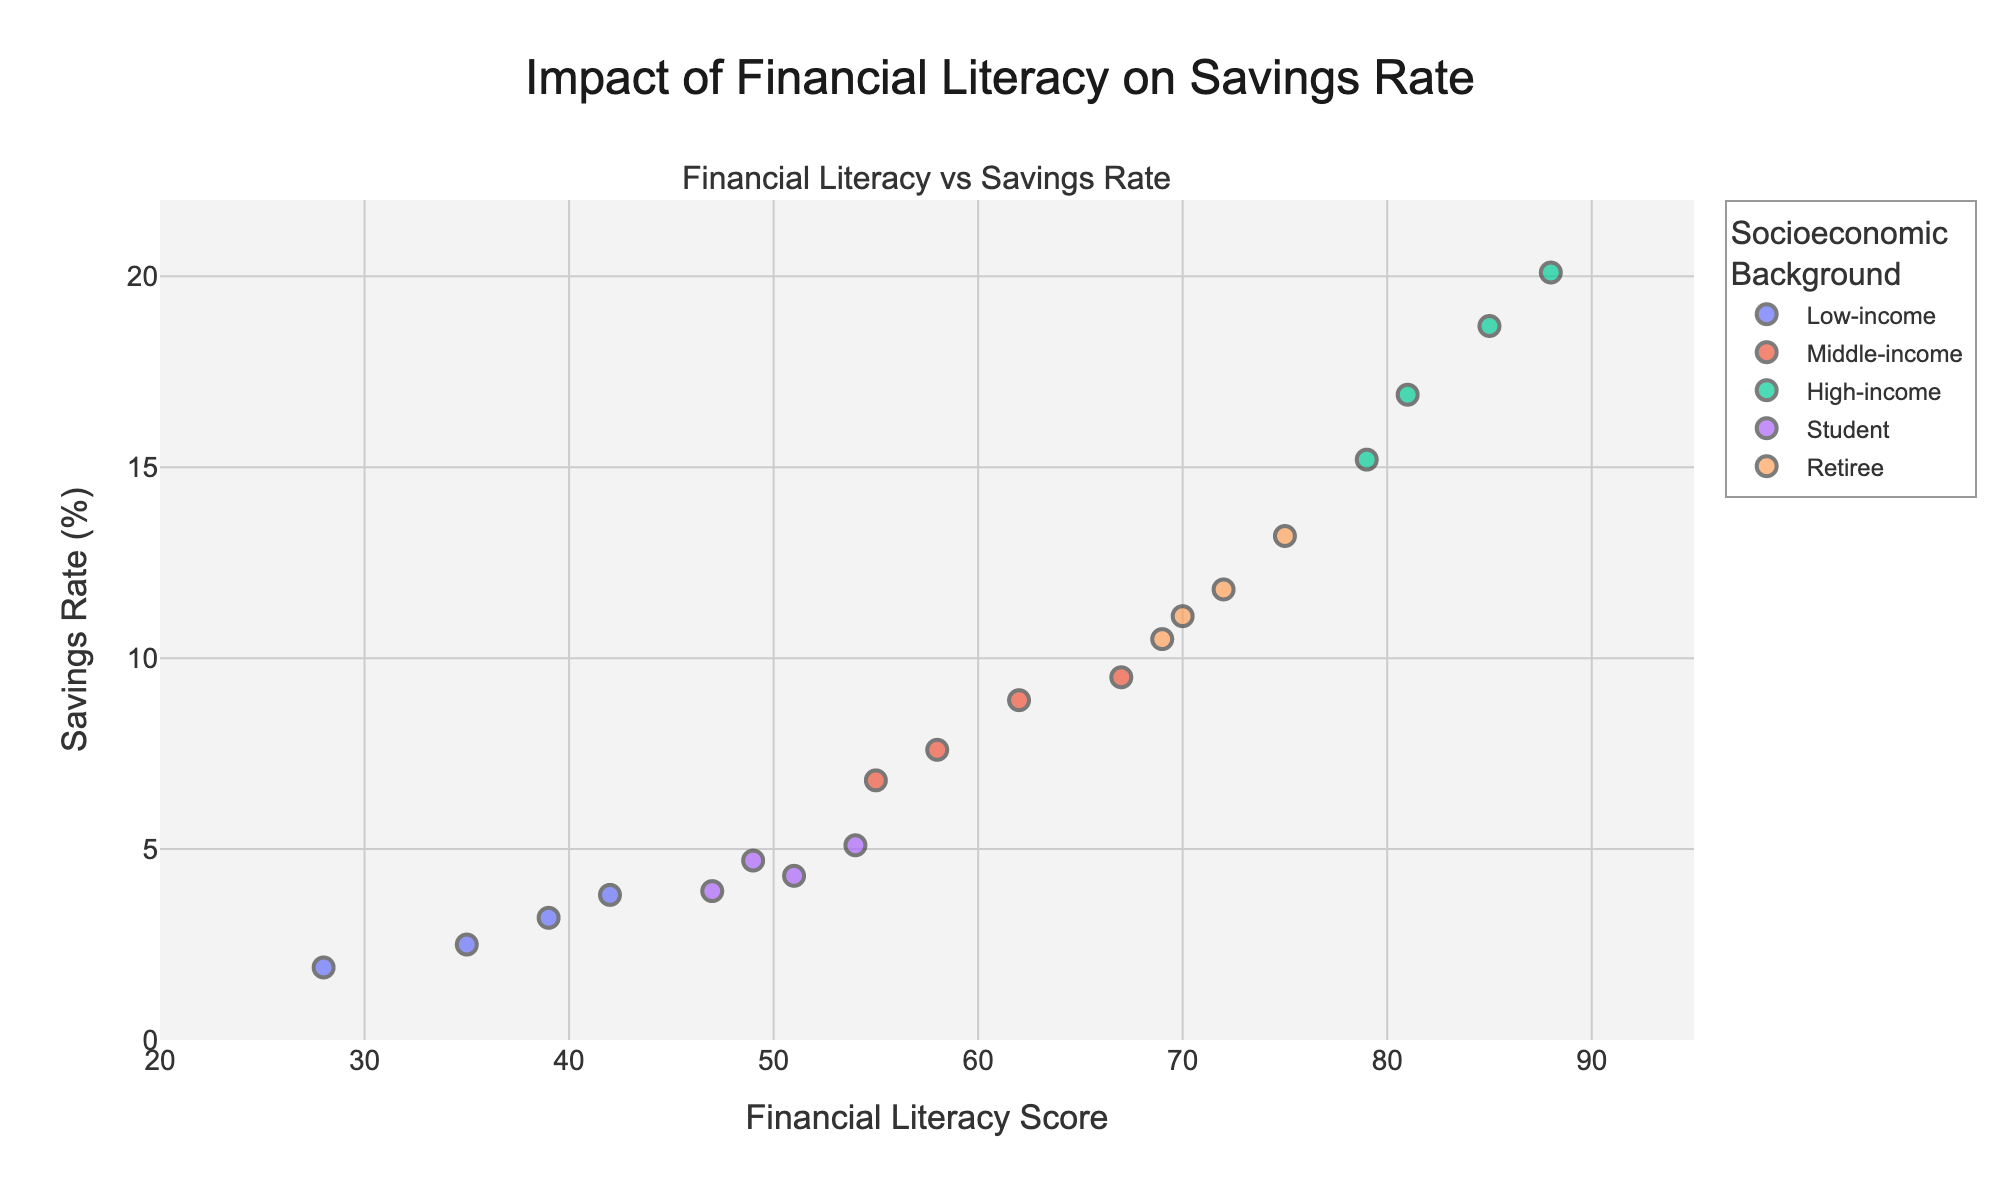what is the title of the figure? The title of the figure is centered at the top and easily readable. It is "Impact of Financial Literacy on Savings Rate"
Answer: Impact of Financial Literacy on Savings Rate What is the x-axis labeled for the figure? The label for the x-axis is clearly mentioned right below it and it reads "Financial Literacy Score"
Answer: Financial Literacy Score How many socioeconomic backgrounds are represented in the figure? By visually inspecting the legend on the right side of the figure, we can see that there are five separate entries corresponding to socio-economic backgrounds: Low-income, Middle-income, High-income, Student, and Retiree.
Answer: 5 What's the general trend between financial literacy scores and savings rates? By observing the scatter plots for different backgrounds, there is a clear upward trend indicating that as financial literacy scores increase, savings rates also tend to increase.
Answer: Upward trend Which group, according to the plotted data, shows the highest financial literacy scores and corresponding savings rates? We refer to the scatter plots for the different groups. The High-income group appears to have the highest values, with financial literacy scores close to 85 and savings rates around 20%.
Answer: High-income What is the savings rate for the most financially literate Low-income individual? Referring to the Low-income scatter points and looking at the highest financial literacy score within this group (around 42), the corresponding savings rate is approximately 3.8%.
Answer: 3.8% How does the highest savings rate compare among the groups? By observing the highest points in each group:
- Low-income: ~3.8%
- Middle-income: ~9.5%
- High-income: ~20.1%
- Student: ~5.1%
- Retiree: ~13.2%
The High-income group has the highest savings rate among all groups.
Answer: High-income has the highest What's the range of financial literacy scores for the Middle-income group? By looking at the scatter points for the Middle-income group, the scores range from approximately 55 to 67.
Answer: 55 to 67 Considering the Retiree group, how much does the average savings rate differ from the lowest to the highest literacy score within the group? First identify the savings rates for Retiree group:
- Lowest financial literacy score (69): savings rate ~10.5%
- Highest financial literacy score (75): savings rate ~13.2%
The difference in savings rates is 13.2% - 10.5% = 2.7%
Answer: 2.7% Which socioeconomic background has the most densely concentrated data points? By observing the density of scatter points in the figure, the Student group has closely placed data points compared to other groups indicating a higher concentration.
Answer: Student 